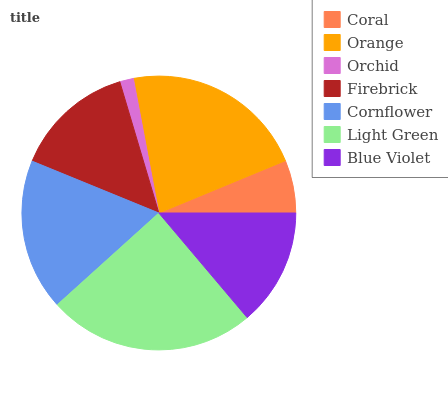Is Orchid the minimum?
Answer yes or no. Yes. Is Light Green the maximum?
Answer yes or no. Yes. Is Orange the minimum?
Answer yes or no. No. Is Orange the maximum?
Answer yes or no. No. Is Orange greater than Coral?
Answer yes or no. Yes. Is Coral less than Orange?
Answer yes or no. Yes. Is Coral greater than Orange?
Answer yes or no. No. Is Orange less than Coral?
Answer yes or no. No. Is Firebrick the high median?
Answer yes or no. Yes. Is Firebrick the low median?
Answer yes or no. Yes. Is Light Green the high median?
Answer yes or no. No. Is Orange the low median?
Answer yes or no. No. 